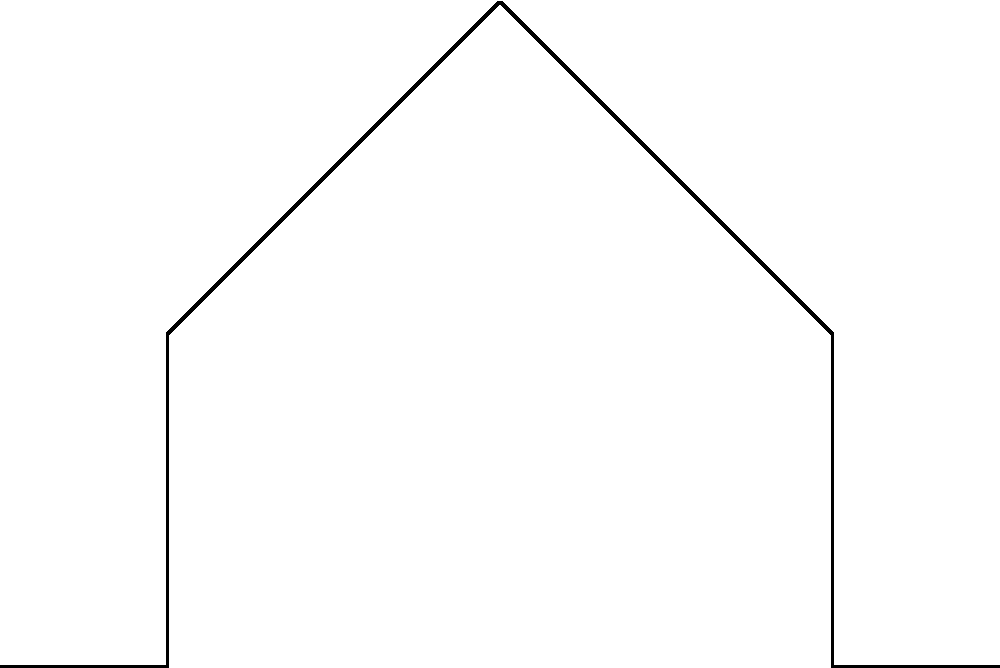In the cross-sectional diagram of an ancient Roman aqueduct, what structural feature allows for the efficient distribution of forces and contributes to its long-term stability? How does this relate to the concept of the arch in Roman engineering? To answer this question, let's analyze the structural features of the Roman aqueduct cross-section:

1. Shape analysis: The cross-section shows an inverted U-shape with curved upper sections (points A, B, and C).

2. Arch identification: The curved upper section forms an arch, a key element in Roman engineering.

3. Force distribution: The arch shape distributes the weight and pressure from the top (point A) outwards to the sides (points B and C).

4. Compressive strength: Stone, the primary material used in aqueducts, has excellent compressive strength.

5. Lateral forces: The arch shape converts vertical forces into lateral forces, which are then absorbed by the thick side walls.

6. Long-term stability: This efficient force distribution minimizes stress concentrations, contributing to the structure's longevity.

7. Historical context: Roman engineers perfected the use of arches in various structures, including aqueducts, bridges, and buildings.

8. Water pressure: The arch shape also helps contain the internal water pressure, represented by the blue line in the diagram.

9. Comparison to modern engineering: This principle is still used in modern structural engineering, showcasing the advanced nature of Roman engineering for its time.

The arch shape is the key structural feature that allows for efficient force distribution and contributes to the aqueduct's long-term stability, demonstrating the Romans' mastery of engineering principles.
Answer: The arch shape, efficiently distributing forces outward and minimizing stress concentrations. 